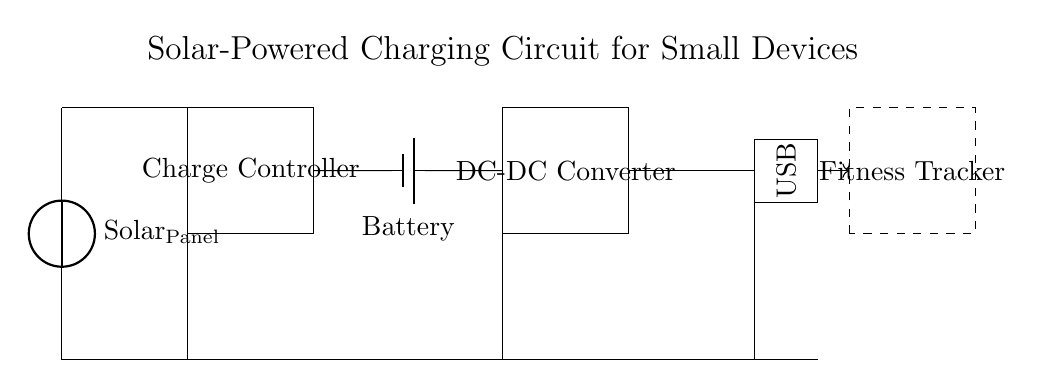What type of power source is used in this circuit? The circuit diagram shows a solar panel as the power source, indicated by the label at the top of the circuit.
Answer: Solar panel What is the function of the charge controller? The charge controller manages the energy flow from the solar panel to the battery, preventing overcharging and ensuring proper voltage levels.
Answer: Energy management How many components are directly connected to the battery? The battery is connected to the charge controller and the DC-DC converter, totaling two components connected directly.
Answer: Two components What is the output voltage type for the USB? The USB output typically provides a DC voltage suitable for charging small devices, as seen in the labeled output section.
Answer: DC voltage What is the purpose of the DC-DC converter in this circuit? The DC-DC converter steps down or regulates the voltage from the battery to a suitable level for charging devices like fitness trackers.
Answer: Voltage regulation What kind of device is represented in the dashed rectangle? The dashed rectangle indicates a fitness tracker, which is a small electronic device that can be charged using the output from the USB.
Answer: Fitness tracker 